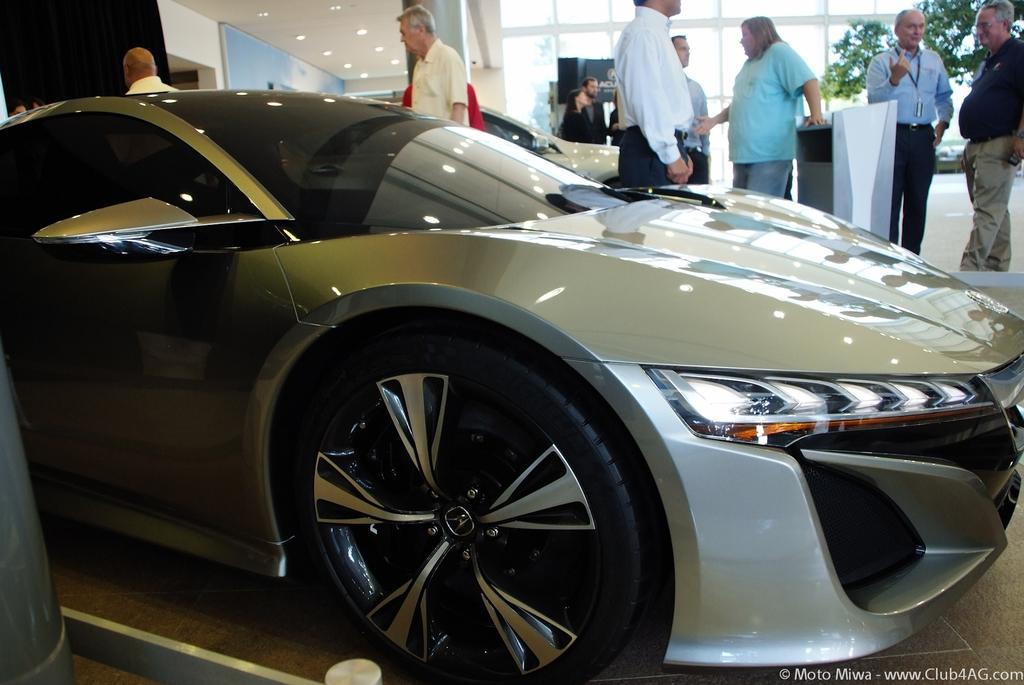What is the main subject of the image? The main subject of the image is a car parked on the floor. Can you describe the people in the background of the image? There are people standing in the background of the image. Where is the watermark located in the image? The watermark is on the bottom right side of the image. How many beads are scattered around the car in the image? There are no beads present in the image. 